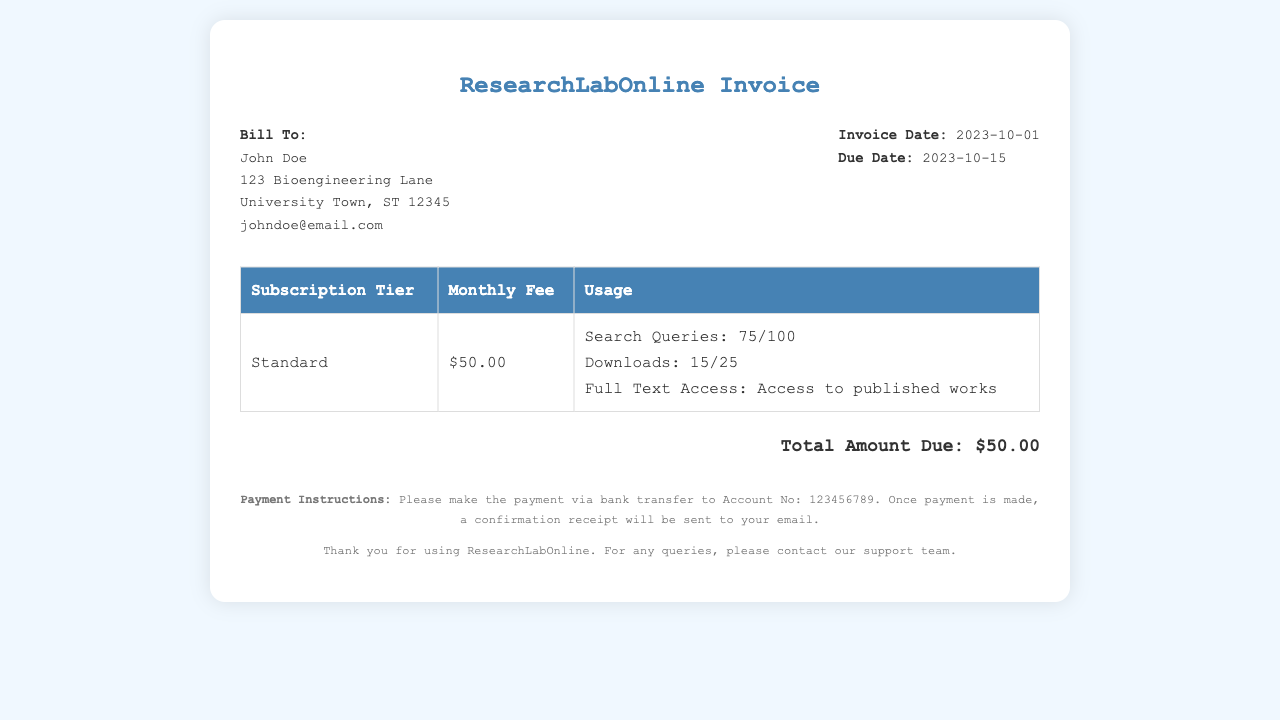What is the invoice date? The invoice date is listed in the document under the invoice details section, specifically marked as "Invoice Date:".
Answer: 2023-10-01 What is the due date? The due date can be found in the same section as the invoice date, clearly labeled as "Due Date:".
Answer: 2023-10-15 What is the monthly fee for the subscription tier? The monthly fee is specified in the table under the "Monthly Fee" column for each subscription tier.
Answer: $50.00 How many search queries have been used? The document specifies the usage under the "Standard" subscription tier, stating the current number of search queries used and the maximum allowed.
Answer: 75/100 What is the maximum number of downloads allowed? The maximum number of downloads is referenced in the usage limits within the subscription details.
Answer: 25 What is the total amount due? The total amount due is clearly stated at the bottom of the document next to "Total Amount Due:".
Answer: $50.00 What is the subscription tier name? The subscription tier name is indicated at the beginning of the row in the table.
Answer: Standard What should be done after making the payment? The document provides specific instructions on what to expect after the payment is made under "Payment Instructions".
Answer: Confirmation receipt Who is billed for this invoice? The billing information is located at the top of the document, under "Bill To:".
Answer: John Doe 